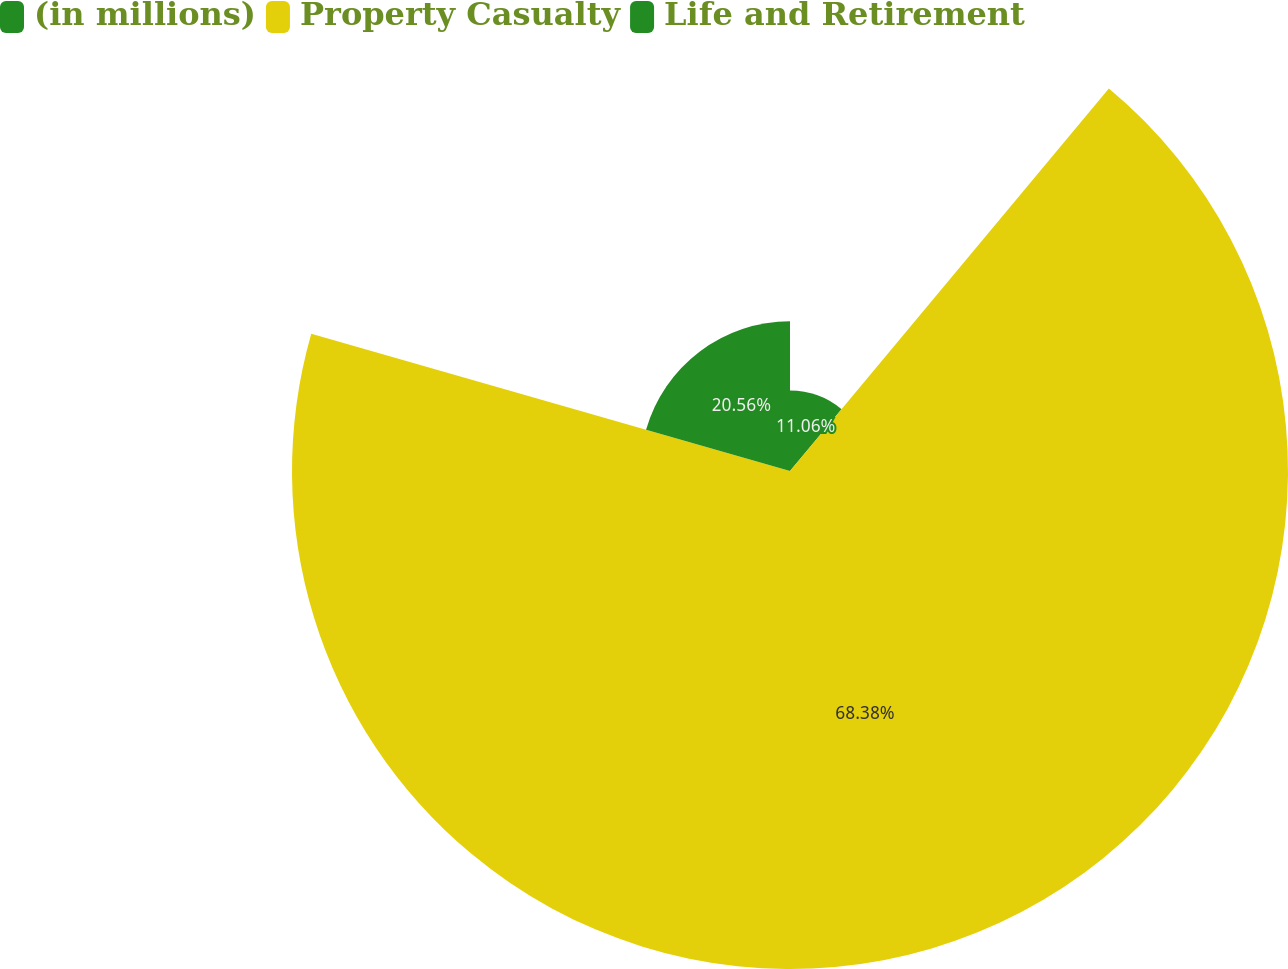Convert chart to OTSL. <chart><loc_0><loc_0><loc_500><loc_500><pie_chart><fcel>(in millions)<fcel>Property Casualty<fcel>Life and Retirement<nl><fcel>11.06%<fcel>68.38%<fcel>20.56%<nl></chart> 